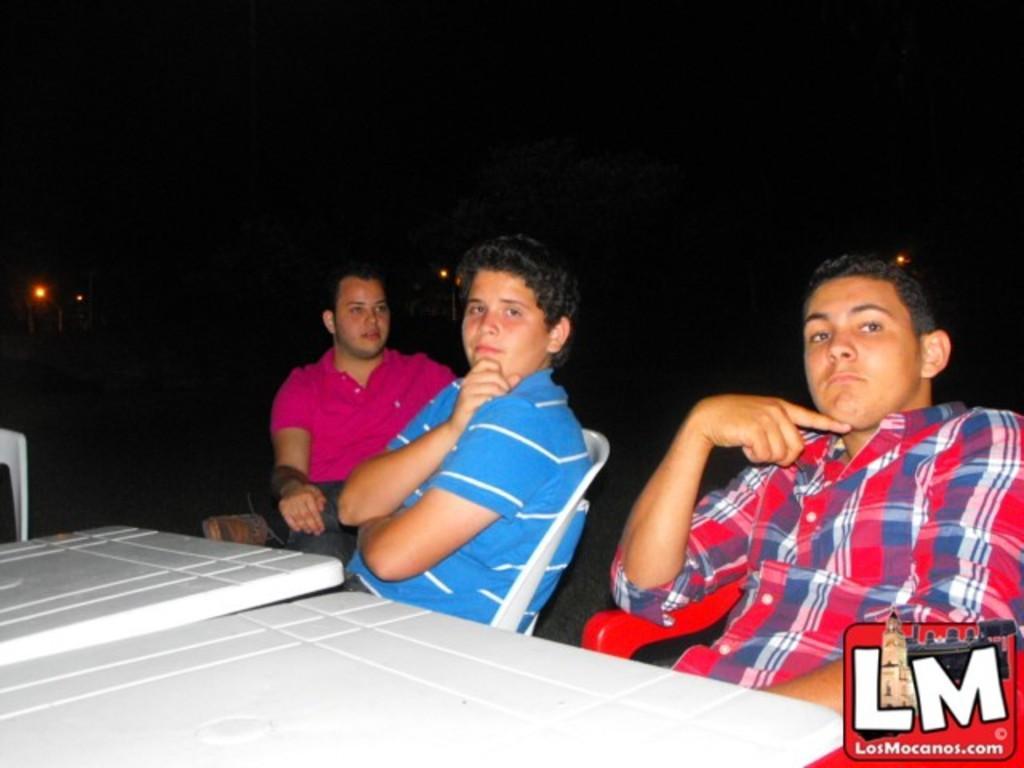Could you give a brief overview of what you see in this image? There are three men sitting on chairs,in front of these men we can see tables. In the background we can see lights and it is dark. 